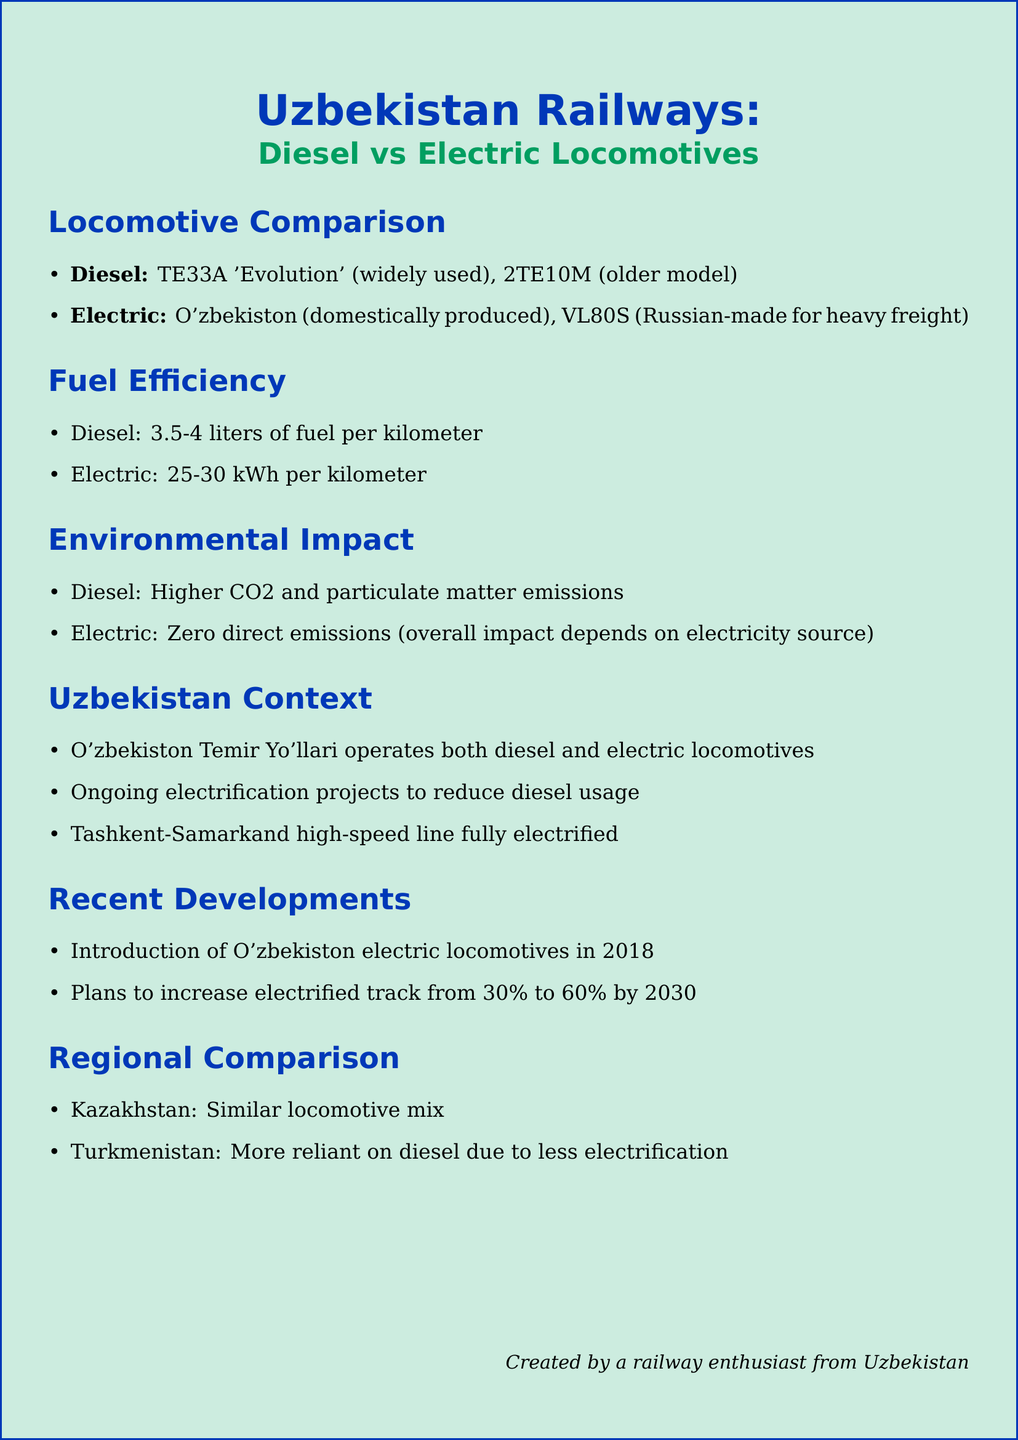What is the modern diesel locomotive widely used in Uzbekistan? The modern diesel locomotive that is widely used in Uzbekistan is the TE33A 'Evolution'.
Answer: TE33A 'Evolution' What is the fuel consumption of diesel locomotives per kilometer? Diesel locomotives consume about 3.5-4 liters of fuel per kilometer according to the document.
Answer: 3.5-4 liters What is the electricity consumption of electric locomotives per kilometer? Electric locomotives use about 25-30 kWh per kilometer.
Answer: 25-30 kWh What is the percentage of electrified track planned by Uzbekistan by 2030? The document states plans to increase electrified track from 30% to 60% by 2030.
Answer: 60% Which electric locomotive is domestically produced in Uzbekistan? The document notes that the O'zbekiston electric locomotive is domestically produced.
Answer: O'zbekiston What are the major emissions produced by diesel locomotives? Diesel locomotives emit more CO2 and particulate matter.
Answer: CO2 and particulate matter What is the primary reason for ongoing electrification projects in Uzbekistan? The ongoing electrification projects aim to reduce diesel usage in the railway system.
Answer: Reduce diesel usage Which neighboring country is noted for having a similar locomotive mix? Kazakhstan is mentioned as using a similar locomotive mix in the document.
Answer: Kazakhstan What is the environmental impact of electric locomotives regarding direct emissions? Electric locomotives produce zero direct emissions according to the document.
Answer: Zero direct emissions 